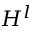<formula> <loc_0><loc_0><loc_500><loc_500>H ^ { l }</formula> 